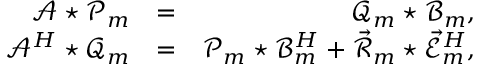<formula> <loc_0><loc_0><loc_500><loc_500>\begin{array} { r l r } { \mathcal { A } ^ { * } \mathcal { P } _ { m } } & { = } & { \mathcal { Q } _ { m } ^ { * } \mathcal { B } _ { m } , } \\ { \mathcal { A } ^ { H } ^ { * } \mathcal { Q } _ { m } } & { = } & { \mathcal { P } _ { m } ^ { * } \mathcal { B } _ { m } ^ { H } + \vec { \mathcal { R } } _ { m } ^ { * } \vec { \mathcal { E } } _ { m } ^ { H } , } \end{array}</formula> 